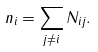Convert formula to latex. <formula><loc_0><loc_0><loc_500><loc_500>n _ { i } = \sum _ { j \ne i } N _ { i j } .</formula> 